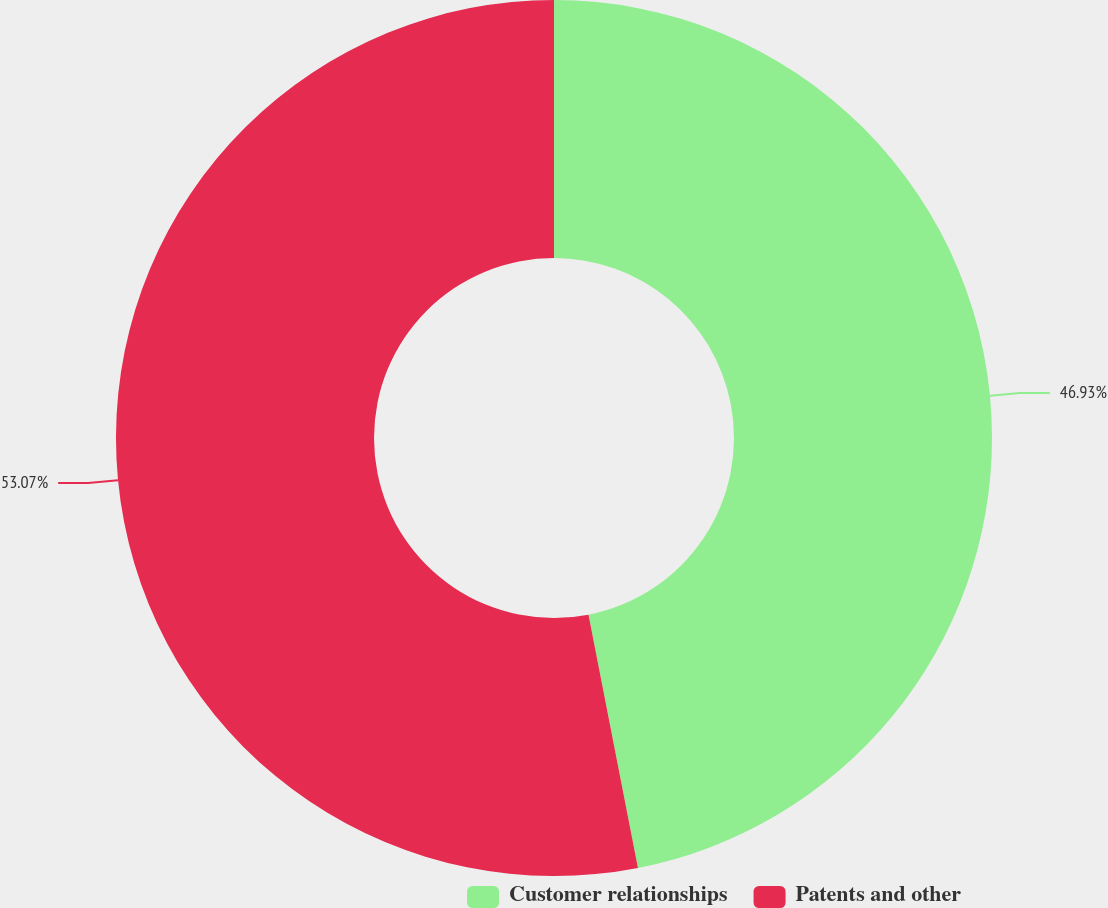<chart> <loc_0><loc_0><loc_500><loc_500><pie_chart><fcel>Customer relationships<fcel>Patents and other<nl><fcel>46.93%<fcel>53.07%<nl></chart> 